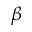Convert formula to latex. <formula><loc_0><loc_0><loc_500><loc_500>\beta</formula> 